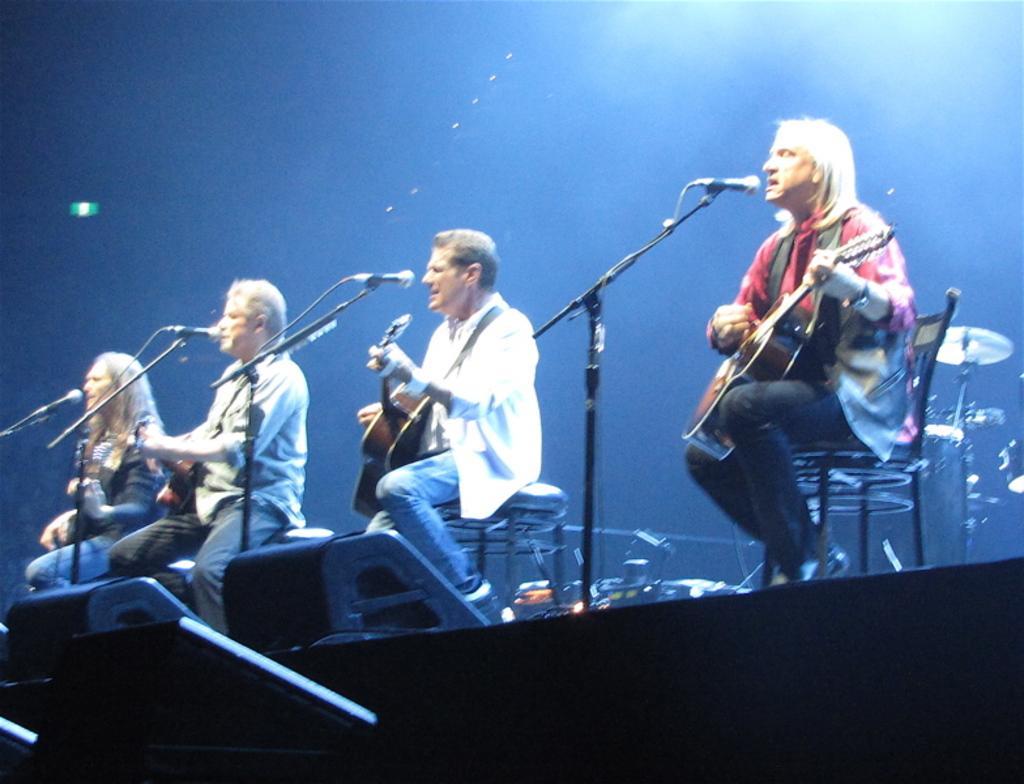In one or two sentences, can you explain what this image depicts? There are four people in image who are sitting on chair and playing their musical instrument in front of a microphone, on top there is a light. 